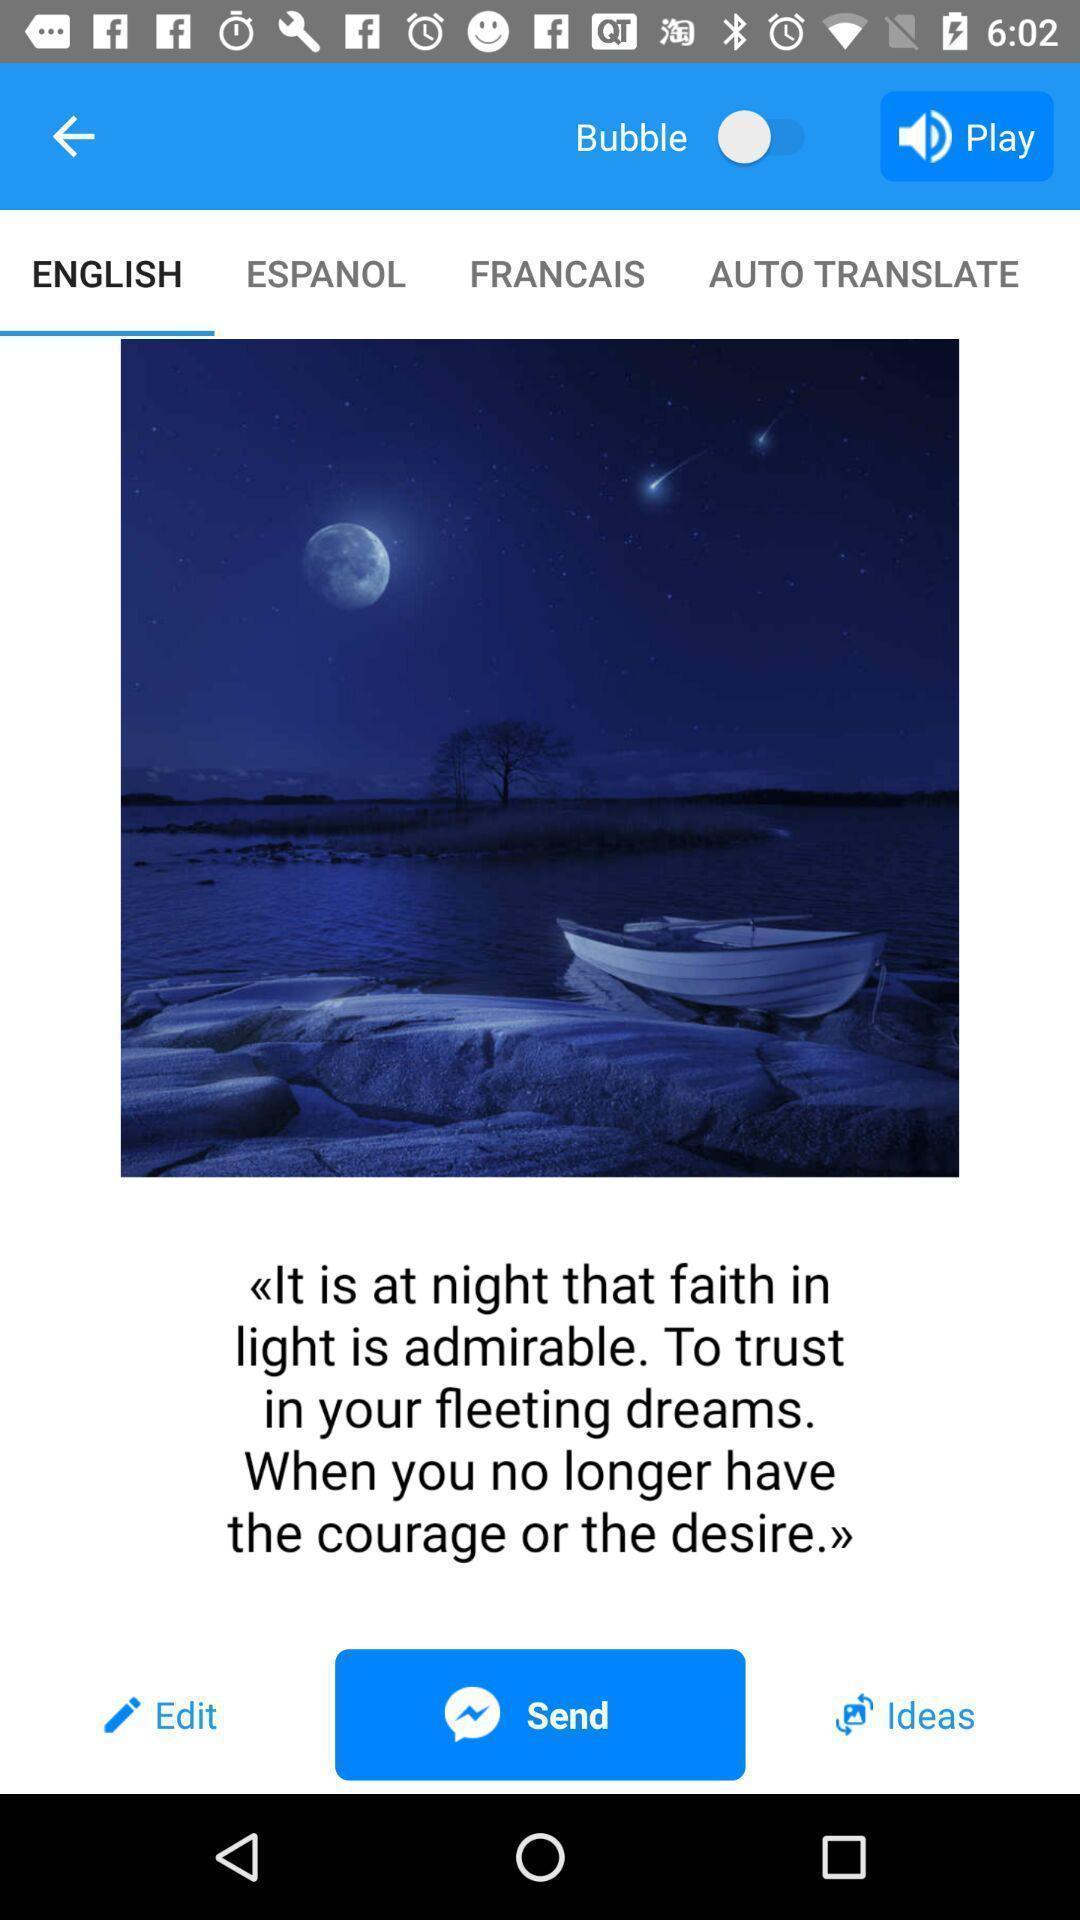Describe the content in this image. Page displaying the image of faith in light. 